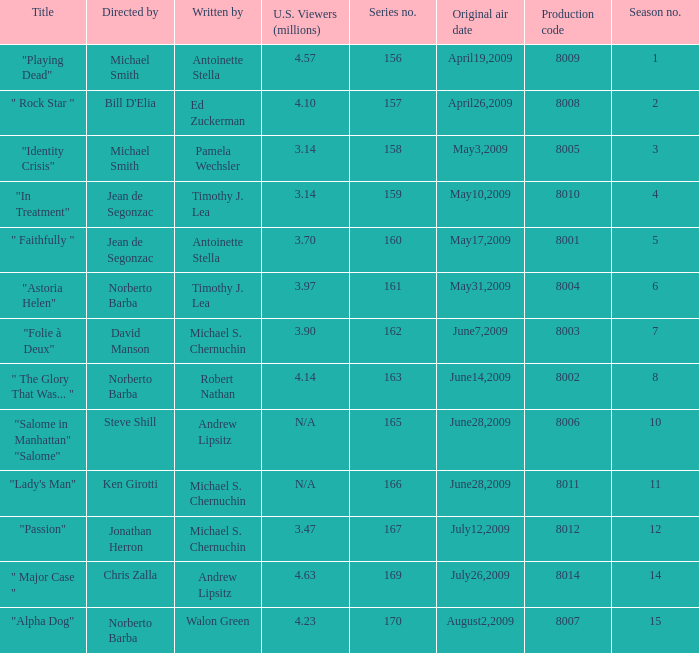Who are the writers when the production code is 8011? Michael S. Chernuchin. 